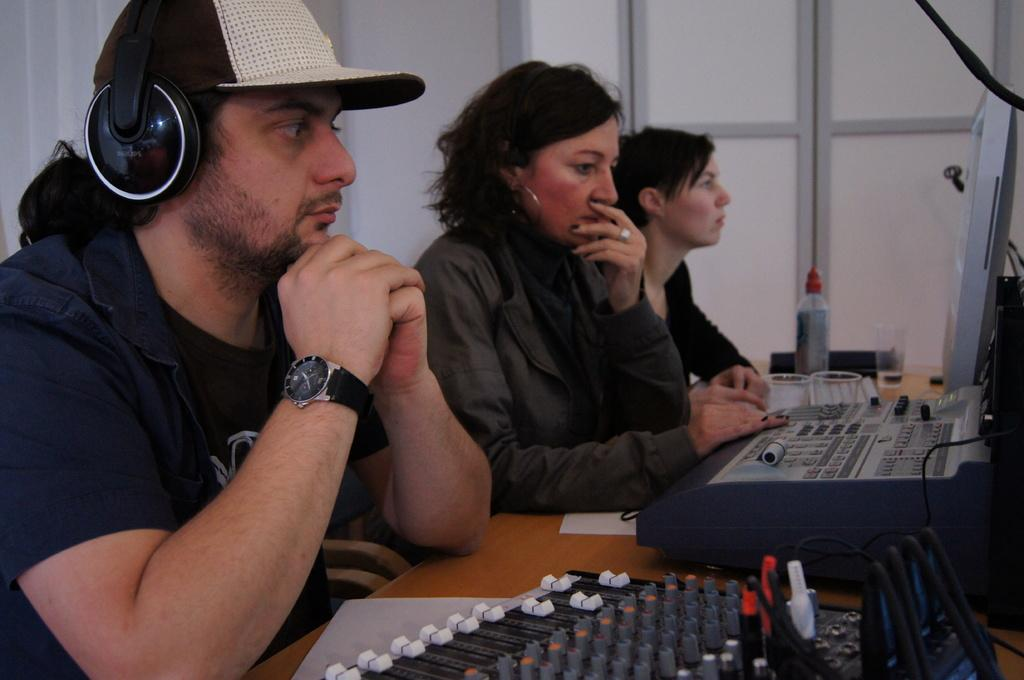How many people are present in the image? There are three people in the image. What are the people doing in the image? The people are sitting in front of a table and working on the equipment. What can be seen on the table in the image? There is equipment on the table. What is the color of the wall behind the people? The wall behind the people is white. How many clocks are hanging on the wall behind the people? There are no clocks visible on the wall behind the people in the image. What type of spring is being used by the people in the image? There is no spring present in the image; the people are working on equipment. 